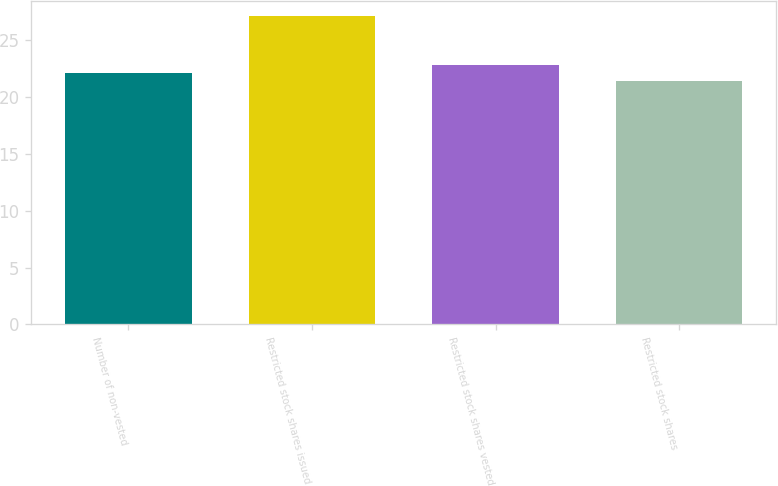Convert chart to OTSL. <chart><loc_0><loc_0><loc_500><loc_500><bar_chart><fcel>Number of non-vested<fcel>Restricted stock shares issued<fcel>Restricted stock shares vested<fcel>Restricted stock shares<nl><fcel>22.13<fcel>27.12<fcel>22.83<fcel>21.43<nl></chart> 